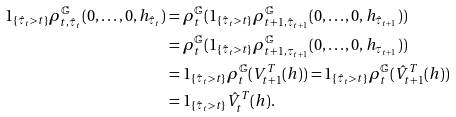<formula> <loc_0><loc_0><loc_500><loc_500>1 _ { \{ \hat { \tau } _ { t } > t \} } \rho ^ { \mathbb { G } } _ { t , \hat { \tau } _ { t } } ( 0 , \dots , 0 , h _ { \hat { \tau } _ { t } } ) & = \rho ^ { \mathbb { G } } _ { t } ( 1 _ { \{ \hat { \tau } _ { t } > t \} } \rho ^ { \mathbb { G } } _ { t + 1 , \hat { \tau } _ { t + 1 } } ( 0 , \dots , 0 , h _ { \hat { \tau } _ { t + 1 } } ) ) \\ & = \rho ^ { \mathbb { G } } _ { t } ( 1 _ { \{ \hat { \tau } _ { t } > t \} } \rho ^ { \mathbb { G } } _ { t + 1 , \tau _ { t + 1 } } ( 0 , \dots , 0 , h _ { \tau _ { t + 1 } } ) ) \\ & = 1 _ { \{ \hat { \tau } _ { t } > t \} } \rho ^ { \mathbb { G } } _ { t } ( V ^ { T } _ { t + 1 } ( h ) ) = 1 _ { \{ \hat { \tau } _ { t } > t \} } \rho ^ { \mathbb { G } } _ { t } ( \hat { V } ^ { T } _ { t + 1 } ( h ) ) \\ & = 1 _ { \{ \hat { \tau } _ { t } > t \} } \hat { V } ^ { T } _ { t } ( h ) .</formula> 